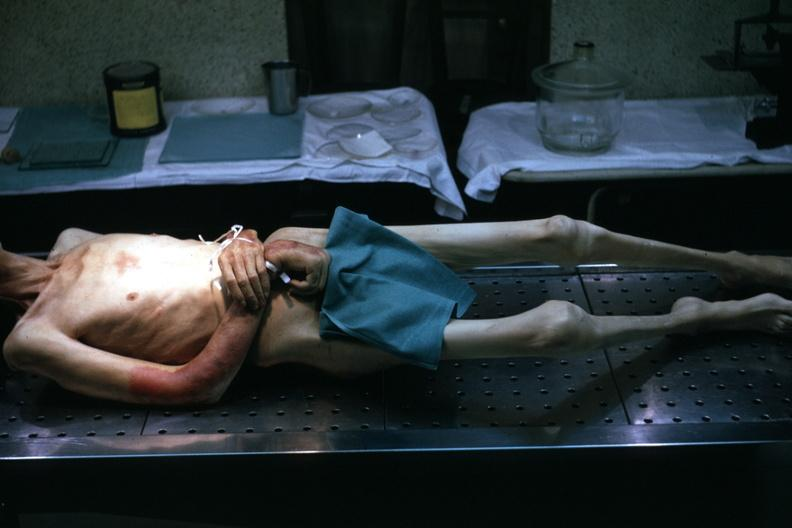what does this image show?
Answer the question using a single word or phrase. Good example tastefully shown with face out of picture and genitalia covered muscle atrophy is striking 